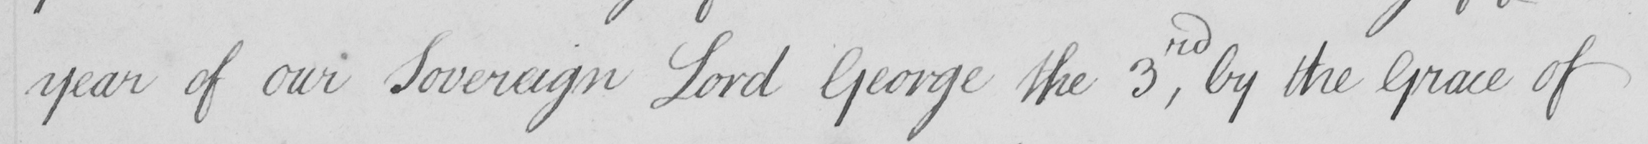Can you tell me what this handwritten text says? year of our Sovereign Lord George the 3rd , by the Grace of 